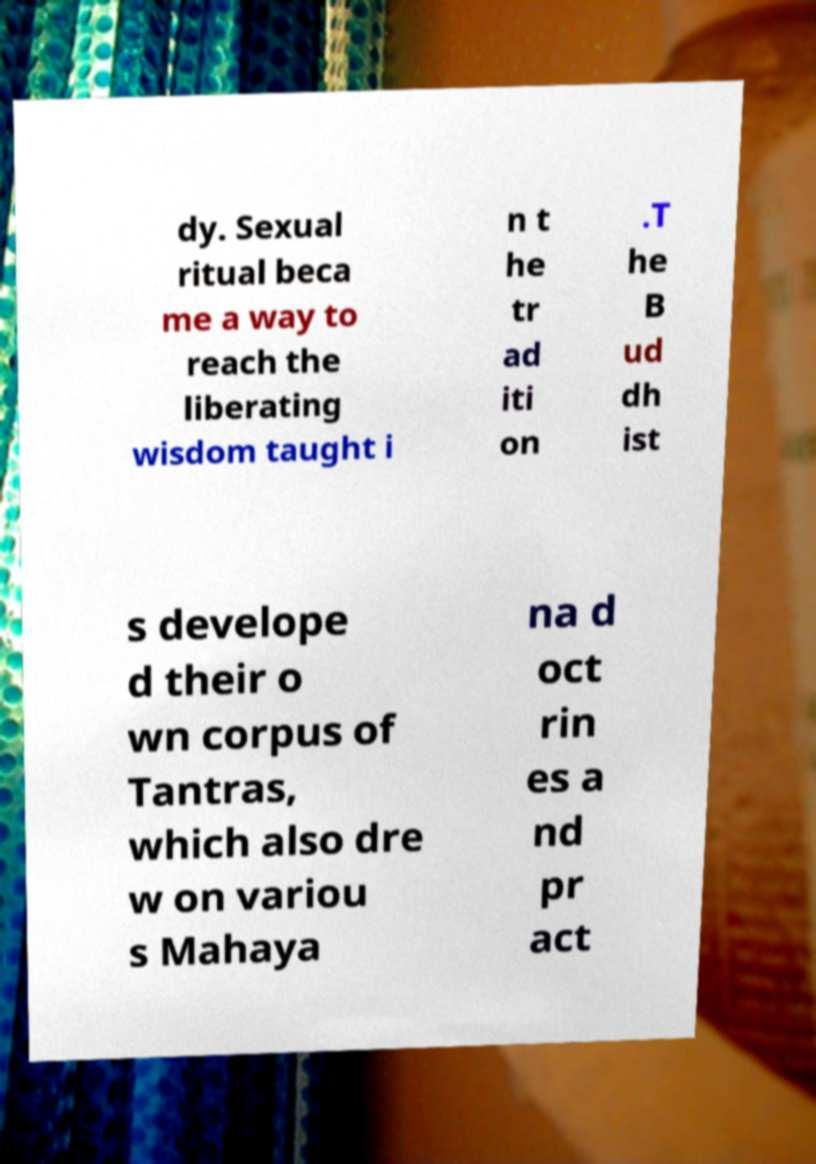For documentation purposes, I need the text within this image transcribed. Could you provide that? dy. Sexual ritual beca me a way to reach the liberating wisdom taught i n t he tr ad iti on .T he B ud dh ist s develope d their o wn corpus of Tantras, which also dre w on variou s Mahaya na d oct rin es a nd pr act 